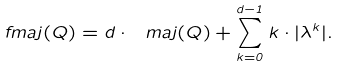Convert formula to latex. <formula><loc_0><loc_0><loc_500><loc_500>\ f m a j ( Q ) = d \cdot \ m a j ( Q ) + \sum _ { k = 0 } ^ { d - 1 } k \cdot | \lambda ^ { k } | .</formula> 